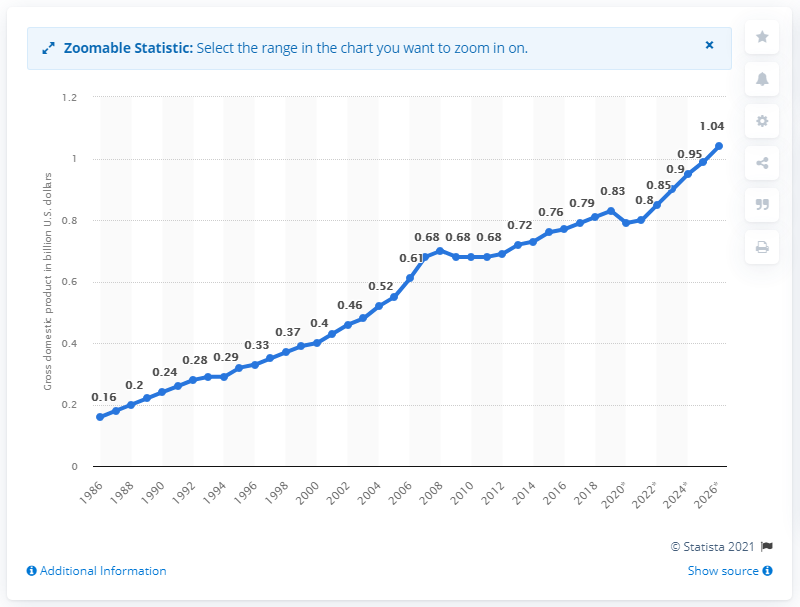Point out several critical features in this image. In 2019, the gross domestic product of St. Vincent and the Grenadines was 0.83. 